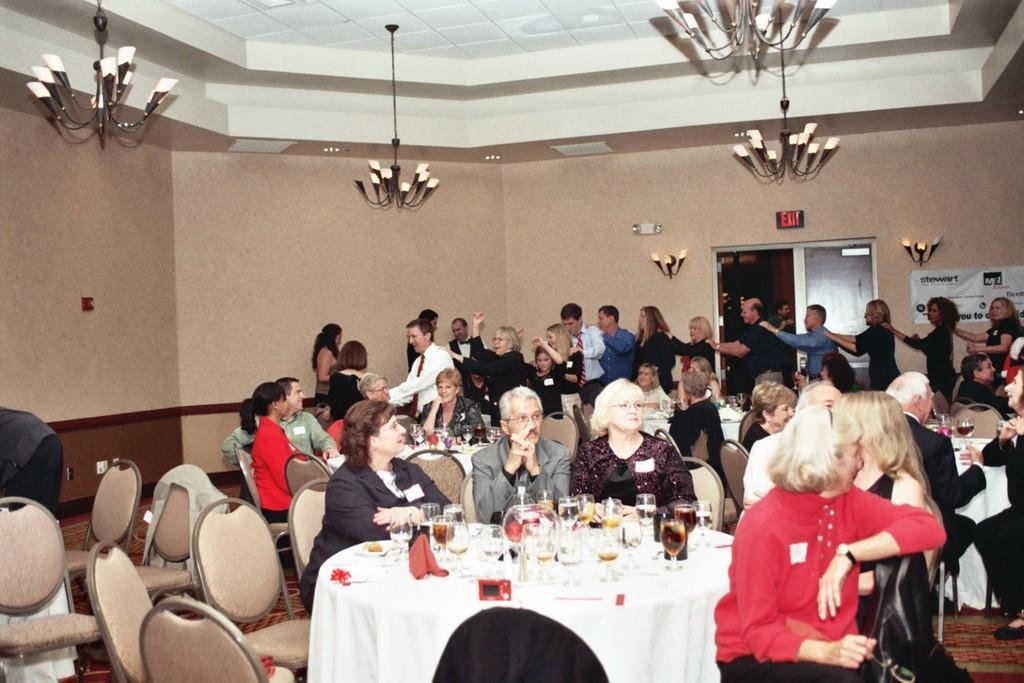How would you summarize this image in a sentence or two? As we can see in the image there is a wall, door, chandeliers, chairs and tables and few people standing and sitting. On table there are glasses and plates. 